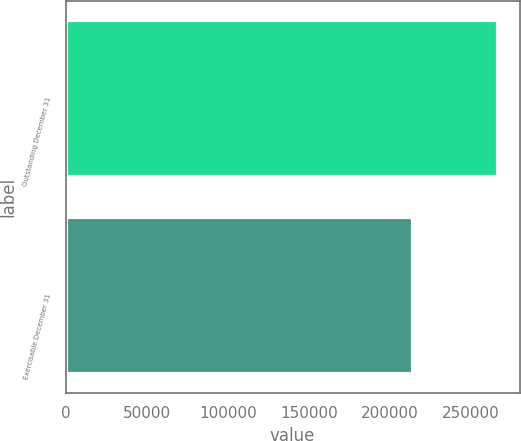Convert chart. <chart><loc_0><loc_0><loc_500><loc_500><bar_chart><fcel>Outstanding December 31<fcel>Exercisable December 31<nl><fcel>266568<fcel>214443<nl></chart> 